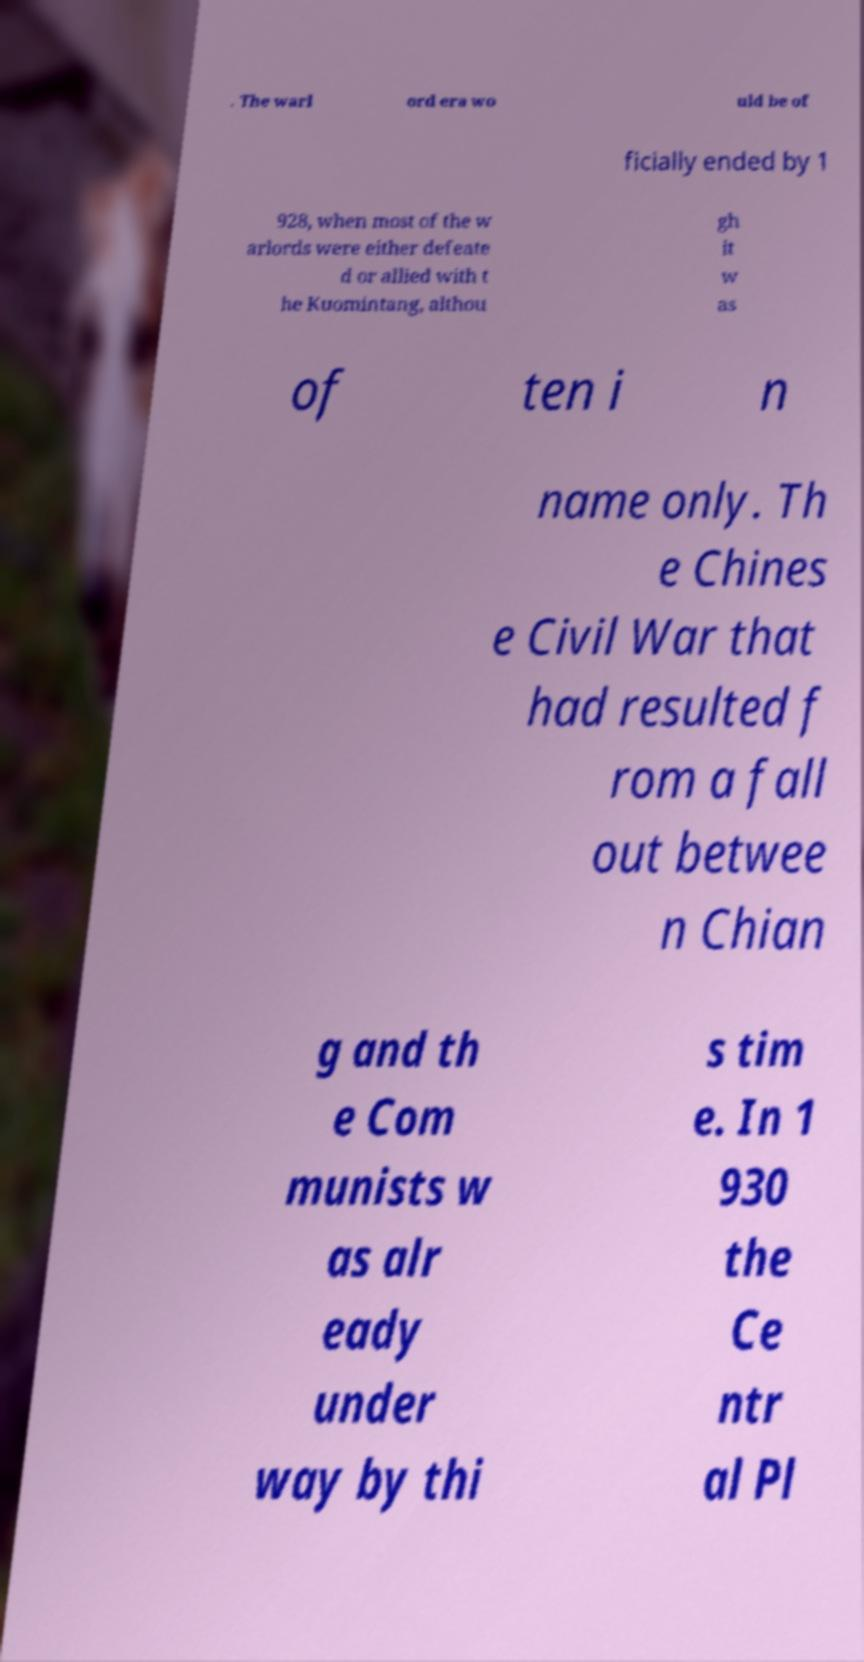Can you accurately transcribe the text from the provided image for me? . The warl ord era wo uld be of ficially ended by 1 928, when most of the w arlords were either defeate d or allied with t he Kuomintang, althou gh it w as of ten i n name only. Th e Chines e Civil War that had resulted f rom a fall out betwee n Chian g and th e Com munists w as alr eady under way by thi s tim e. In 1 930 the Ce ntr al Pl 